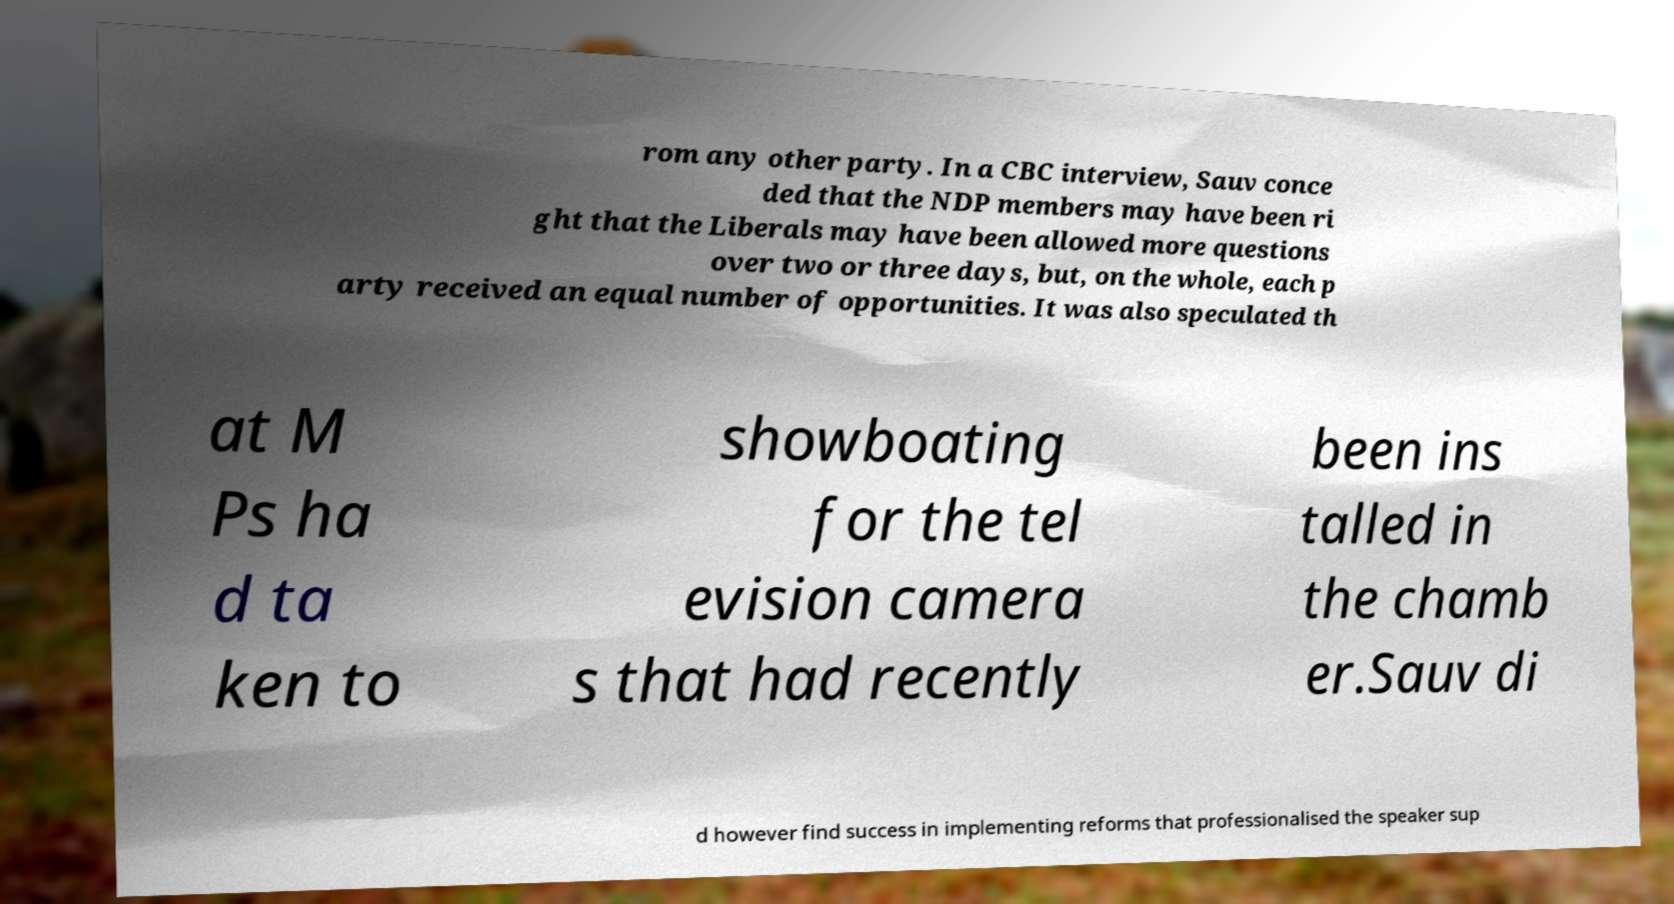What messages or text are displayed in this image? I need them in a readable, typed format. rom any other party. In a CBC interview, Sauv conce ded that the NDP members may have been ri ght that the Liberals may have been allowed more questions over two or three days, but, on the whole, each p arty received an equal number of opportunities. It was also speculated th at M Ps ha d ta ken to showboating for the tel evision camera s that had recently been ins talled in the chamb er.Sauv di d however find success in implementing reforms that professionalised the speaker sup 